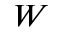Convert formula to latex. <formula><loc_0><loc_0><loc_500><loc_500>W</formula> 